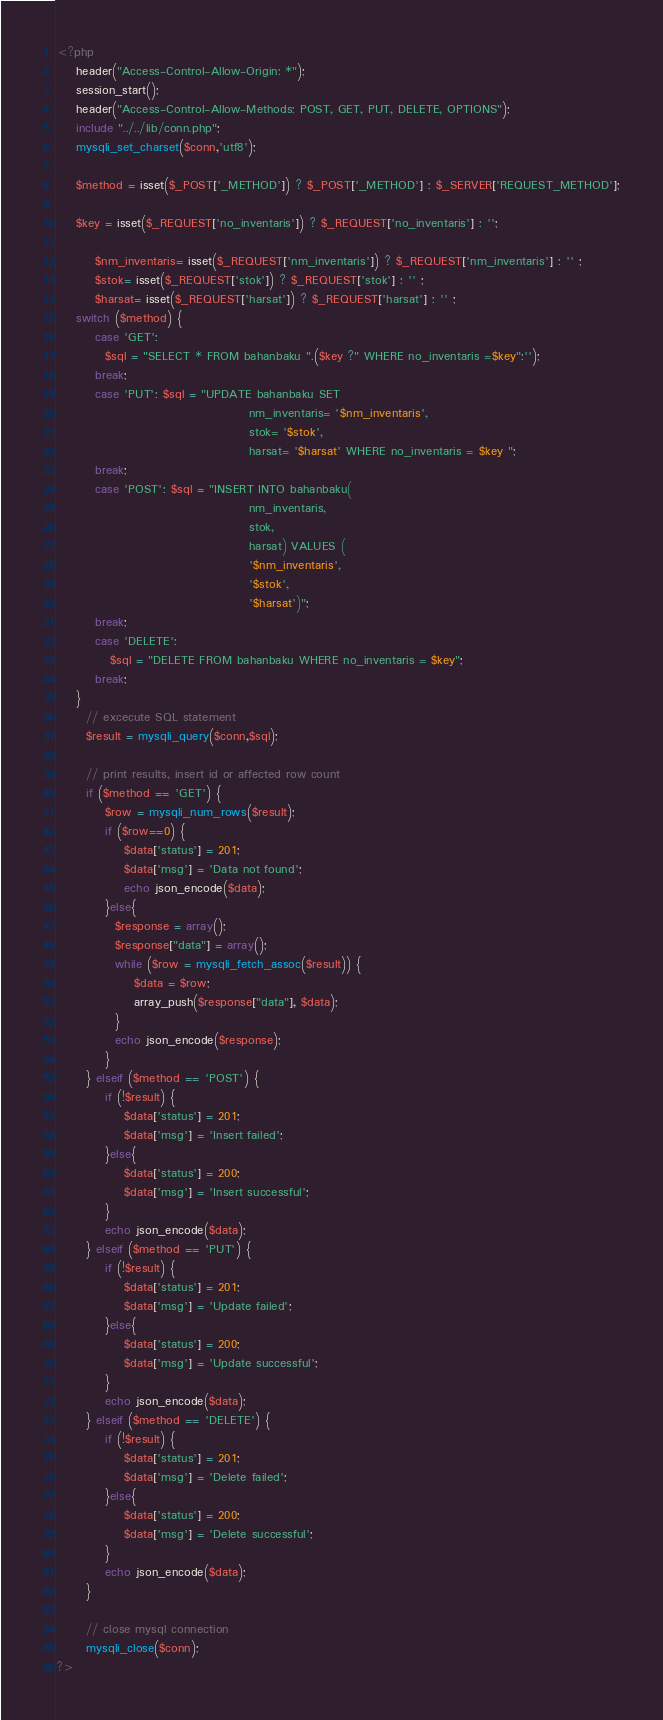Convert code to text. <code><loc_0><loc_0><loc_500><loc_500><_PHP_><?php
	header("Access-Control-Allow-Origin: *");
	session_start();
	header("Access-Control-Allow-Methods: POST, GET, PUT, DELETE, OPTIONS");
    include "../../lib/conn.php";
    mysqli_set_charset($conn,'utf8');

    $method = isset($_POST['_METHOD']) ? $_POST['_METHOD'] : $_SERVER['REQUEST_METHOD'];

    $key = isset($_REQUEST['no_inventaris']) ? $_REQUEST['no_inventaris'] : '';
    
		$nm_inventaris= isset($_REQUEST['nm_inventaris']) ? $_REQUEST['nm_inventaris'] : '' ;
		$stok= isset($_REQUEST['stok']) ? $_REQUEST['stok'] : '' ;
		$harsat= isset($_REQUEST['harsat']) ? $_REQUEST['harsat'] : '' ;
    switch ($method) {
        case 'GET':
          $sql = "SELECT * FROM bahanbaku ".($key ?" WHERE no_inventaris =$key":''); 
        break;
        case 'PUT': $sql = "UPDATE bahanbaku SET 
										nm_inventaris= '$nm_inventaris', 
										stok= '$stok', 
										harsat= '$harsat' WHERE no_inventaris = $key ";
        break;
        case 'POST': $sql = "INSERT INTO bahanbaku( 
										nm_inventaris, 
										stok, 
										harsat) VALUES (
										'$nm_inventaris', 
										'$stok', 
										'$harsat')";
        break;
        case 'DELETE':
           $sql = "DELETE FROM bahanbaku WHERE no_inventaris = $key"; 
        break;
    }       
      // excecute SQL statement
      $result = mysqli_query($conn,$sql);
      
      // print results, insert id or affected row count
      if ($method == 'GET') {
		  $row = mysqli_num_rows($result);
          if ($row==0) {
              $data['status'] = 201;
              $data['msg'] = 'Data not found';
              echo json_encode($data);
          }else{
			$response = array();
			$response["data"] = array();
			while ($row = mysqli_fetch_assoc($result)) {
				$data = $row;
				array_push($response["data"], $data);
			}
			echo json_encode($response);			  
          }  
      } elseif ($method == 'POST') {
          if (!$result) {
              $data['status'] = 201;
              $data['msg'] = 'Insert failed';  
          }else{
              $data['status'] = 200;
              $data['msg'] = 'Insert successful';
          }
          echo json_encode($data);
      } elseif ($method == 'PUT') {
          if (!$result) {
              $data['status'] = 201;
              $data['msg'] = 'Update failed'; 
          }else{
              $data['status'] = 200;
              $data['msg'] = 'Update successful';
          }
          echo json_encode($data);
      } elseif ($method == 'DELETE') {
          if (!$result) {
              $data['status'] = 201;
              $data['msg'] = 'Delete failed';  
          }else{
              $data['status'] = 200;
              $data['msg'] = 'Delete successful';
          }
          echo json_encode($data);
      }
       
      // close mysql connection
      mysqli_close($conn);
?></code> 